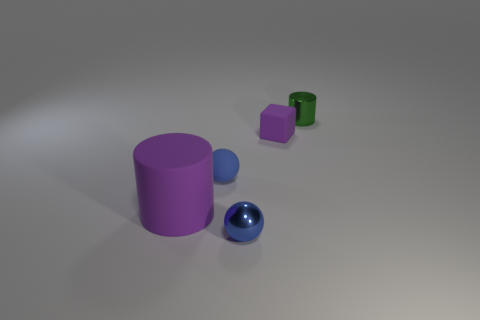Subtract all green cylinders. How many cylinders are left? 1 Add 1 tiny yellow balls. How many objects exist? 6 Subtract 1 cylinders. How many cylinders are left? 1 Subtract all green blocks. Subtract all green cylinders. How many blocks are left? 1 Subtract all purple cylinders. How many cyan blocks are left? 0 Subtract all matte objects. Subtract all large purple objects. How many objects are left? 1 Add 3 large things. How many large things are left? 4 Add 1 cylinders. How many cylinders exist? 3 Subtract 0 gray cylinders. How many objects are left? 5 Subtract all spheres. How many objects are left? 3 